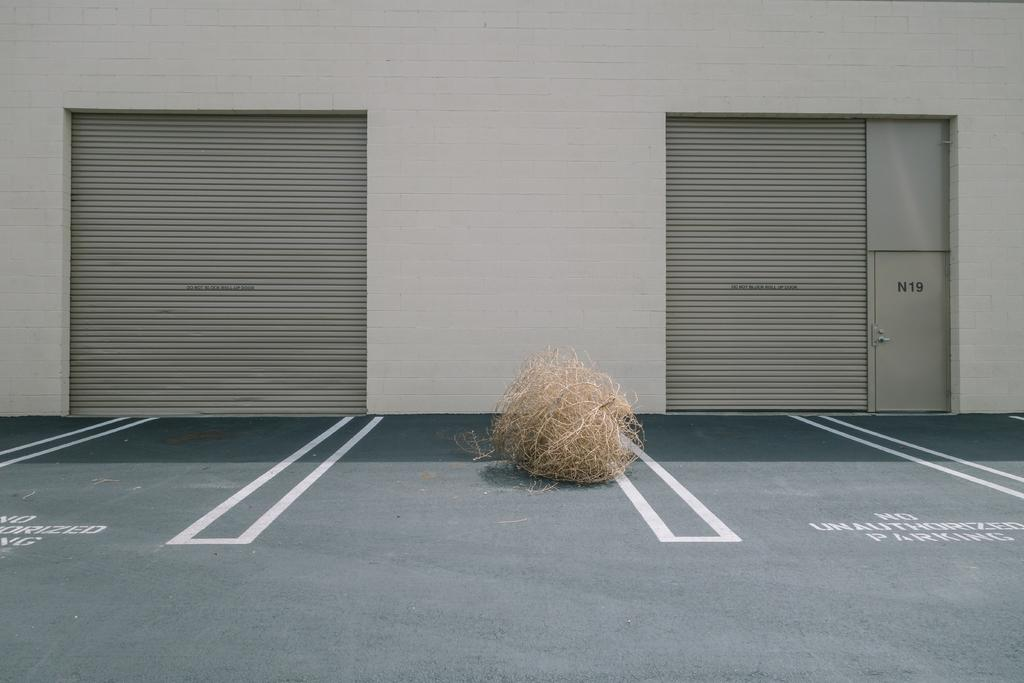What is on the floor in the image? There is a ball of fiber on the floor. What type of window covering can be seen in the image? There are shutters visible in the image. What is a possible entrance or exit in the image? There is a door in the image. What type of architectural feature is present in the image? There is a wall in the image. How many geese are sitting on the pancake in the image? There is no pancake or geese present in the image. What type of comb is being used to style the wall in the image? There is no comb present in the image, and the wall is not being styled. 